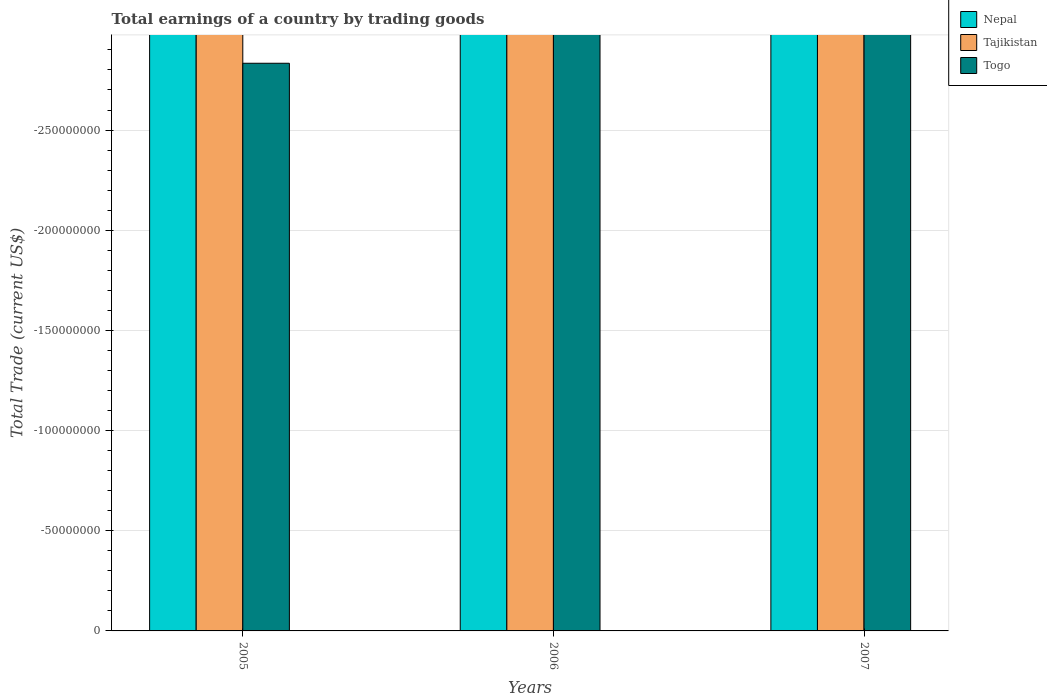How many bars are there on the 3rd tick from the right?
Your response must be concise. 0. What is the label of the 2nd group of bars from the left?
Ensure brevity in your answer.  2006. What is the total earnings in Nepal in 2006?
Make the answer very short. 0. What is the total total earnings in Togo in the graph?
Ensure brevity in your answer.  0. What is the difference between the total earnings in Nepal in 2007 and the total earnings in Togo in 2006?
Your answer should be very brief. 0. In how many years, is the total earnings in Tajikistan greater than -140000000 US$?
Offer a very short reply. 0. Is it the case that in every year, the sum of the total earnings in Togo and total earnings in Tajikistan is greater than the total earnings in Nepal?
Make the answer very short. No. Are all the bars in the graph horizontal?
Offer a very short reply. No. How many years are there in the graph?
Provide a short and direct response. 3. Does the graph contain any zero values?
Provide a succinct answer. Yes. Does the graph contain grids?
Offer a very short reply. Yes. Where does the legend appear in the graph?
Give a very brief answer. Top right. How are the legend labels stacked?
Provide a short and direct response. Vertical. What is the title of the graph?
Make the answer very short. Total earnings of a country by trading goods. What is the label or title of the X-axis?
Your answer should be very brief. Years. What is the label or title of the Y-axis?
Ensure brevity in your answer.  Total Trade (current US$). What is the Total Trade (current US$) of Tajikistan in 2005?
Your answer should be compact. 0. What is the Total Trade (current US$) in Togo in 2005?
Ensure brevity in your answer.  0. What is the Total Trade (current US$) in Nepal in 2006?
Offer a very short reply. 0. What is the Total Trade (current US$) of Nepal in 2007?
Offer a terse response. 0. What is the total Total Trade (current US$) in Nepal in the graph?
Give a very brief answer. 0. What is the total Total Trade (current US$) in Tajikistan in the graph?
Offer a terse response. 0. What is the average Total Trade (current US$) of Nepal per year?
Offer a very short reply. 0. What is the average Total Trade (current US$) of Togo per year?
Offer a very short reply. 0. 